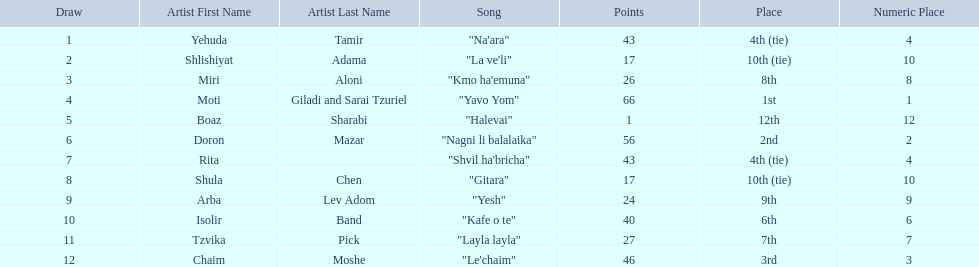Doron mazar, which artist(s) had the most points? Moti Giladi and Sarai Tzuriel. Help me parse the entirety of this table. {'header': ['Draw', 'Artist First Name', 'Artist Last Name', 'Song', 'Points', 'Place', 'Numeric Place'], 'rows': [['1', 'Yehuda', 'Tamir', '"Na\'ara"', '43', '4th (tie)', '4'], ['2', 'Shlishiyat', 'Adama', '"La ve\'li"', '17', '10th (tie)', '10'], ['3', 'Miri', 'Aloni', '"Kmo ha\'emuna"', '26', '8th', '8'], ['4', 'Moti', 'Giladi and Sarai Tzuriel', '"Yavo Yom"', '66', '1st', '1'], ['5', 'Boaz', 'Sharabi', '"Halevai"', '1', '12th', '12'], ['6', 'Doron', 'Mazar', '"Nagni li balalaika"', '56', '2nd', '2'], ['7', 'Rita', '', '"Shvil ha\'bricha"', '43', '4th (tie)', '4'], ['8', 'Shula', 'Chen', '"Gitara"', '17', '10th (tie)', '10'], ['9', 'Arba', 'Lev Adom', '"Yesh"', '24', '9th', '9'], ['10', 'Isolir', 'Band', '"Kafe o te"', '40', '6th', '6'], ['11', 'Tzvika', 'Pick', '"Layla layla"', '27', '7th', '7'], ['12', 'Chaim', 'Moshe', '"Le\'chaim"', '46', '3rd', '3']]} 